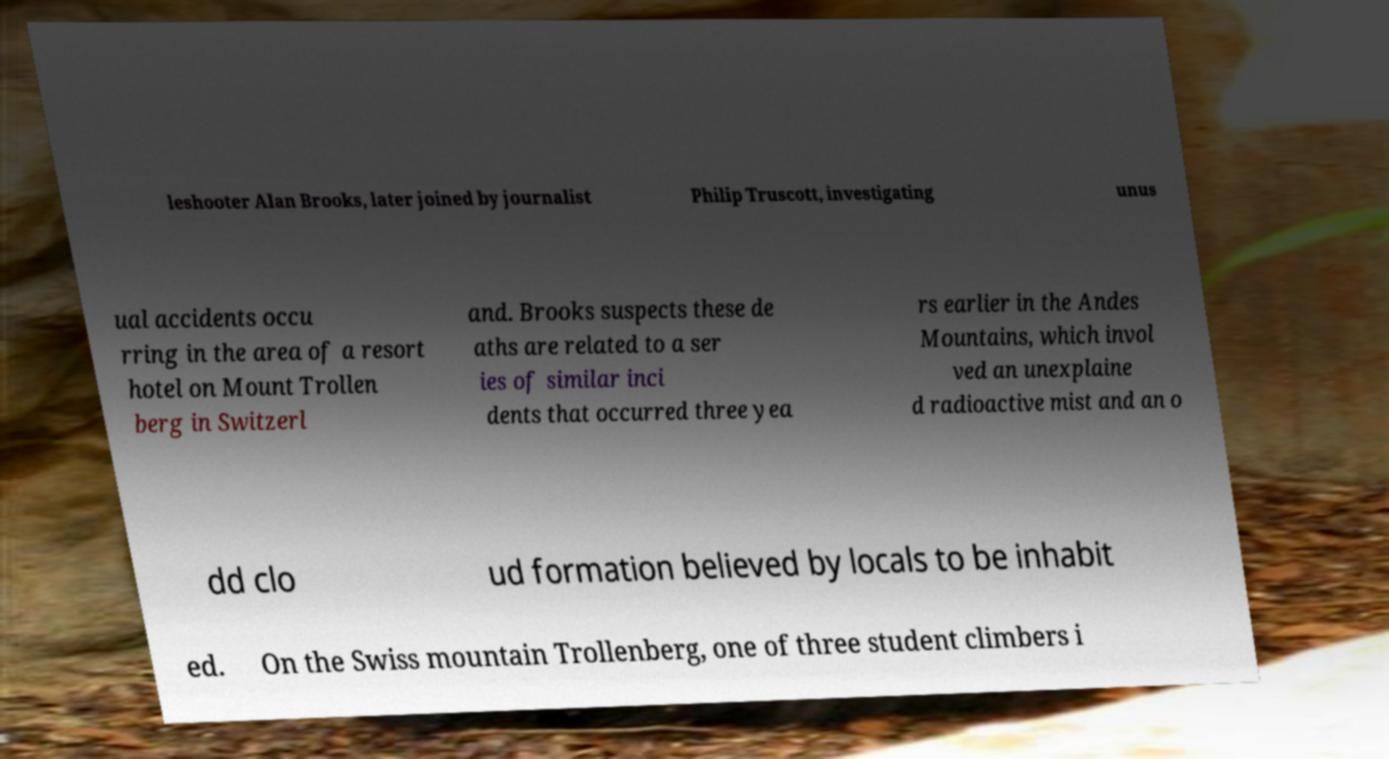What messages or text are displayed in this image? I need them in a readable, typed format. leshooter Alan Brooks, later joined by journalist Philip Truscott, investigating unus ual accidents occu rring in the area of a resort hotel on Mount Trollen berg in Switzerl and. Brooks suspects these de aths are related to a ser ies of similar inci dents that occurred three yea rs earlier in the Andes Mountains, which invol ved an unexplaine d radioactive mist and an o dd clo ud formation believed by locals to be inhabit ed. On the Swiss mountain Trollenberg, one of three student climbers i 